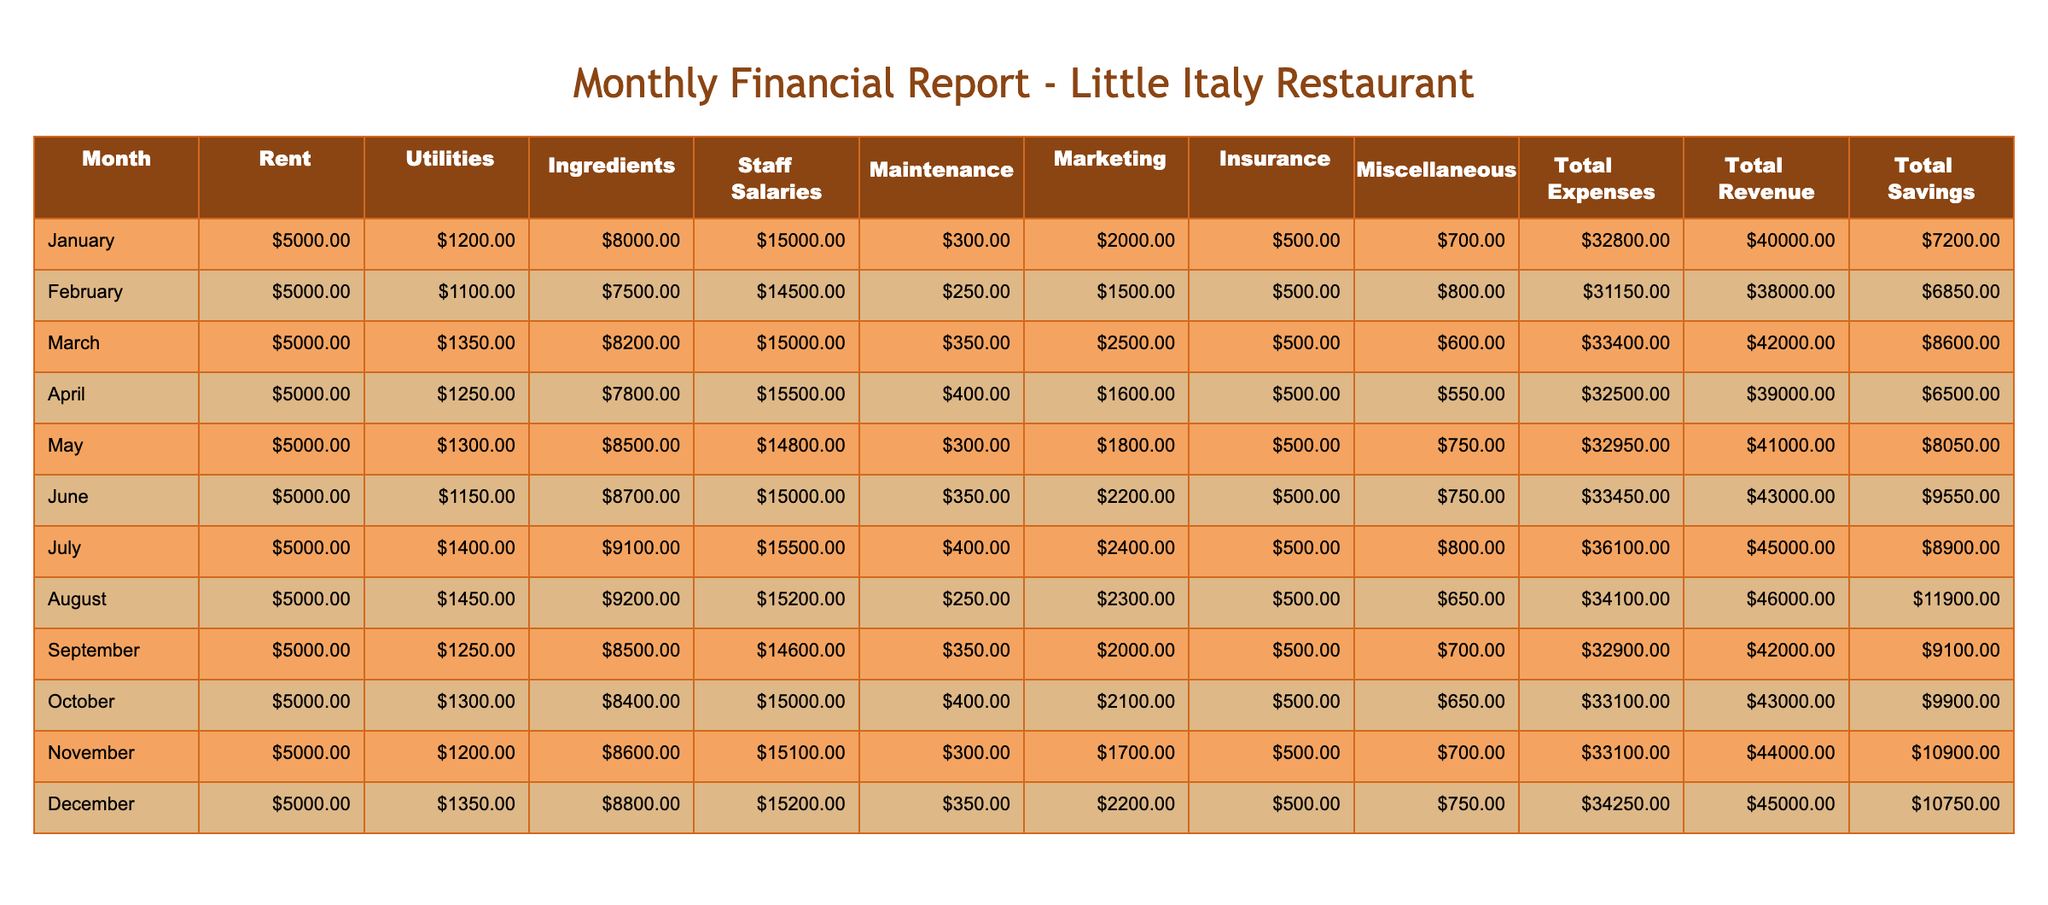What are the total expenses for March? The total expenses for March are directly given in the table under the "Total Expenses" column for the month of March. Referring to the data provided, the total expenses for March amount to 33,400 dollars.
Answer: 33,400 What is the total revenue for the month with the highest savings? To find the month with the highest savings, we look at the "Total Savings" column and identify the highest value, which is 11,900 in August. Then, we check the corresponding "Total Revenue" for August, which is 46,000 dollars.
Answer: 46,000 How much did the restaurant spend on staff salaries in December compared to June? In December, the spending on staff salaries is 15,200 dollars, while in June, it is 15,000 dollars. To compare, we can find the difference: 15,200 - 15,000 = 200 dollars more in December.
Answer: 200 Is the total revenue greater than the total expenses for every month in the table? A comparison of "Total Revenue" to "Total Expenses" for each month reveals that all months indeed have total revenue greater than total expenses, confirming that the statement is true.
Answer: Yes What is the average spending on ingredients over the year? To calculate the average spending on ingredients, sum the values across all months: 8,000 + 7,500 + 8,200 + 7,800 + 8,500 + 8,700 + 9,100 + 9,200 + 8,500 + 8,400 + 8,600 + 8,800 = 101,000. Since there are 12 months, we divide 101,000 by 12 to get an average spending of approximately 8,417 dollars.
Answer: 8,417 